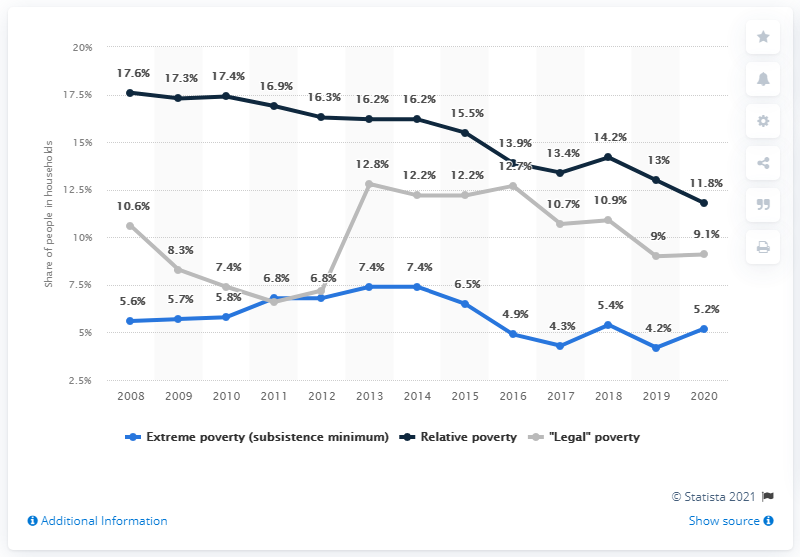Specify some key components in this picture. In 2018, the percentage value of "Legal" poverty was 10.9 percent. The difference between the highest and lowest value of relative poverty is 5.8%. In 2020, the extreme poverty rate in Poland was estimated to be 5.2%. This represents a significant decrease from the previous year and highlights the ongoing efforts to combat poverty in the country. 